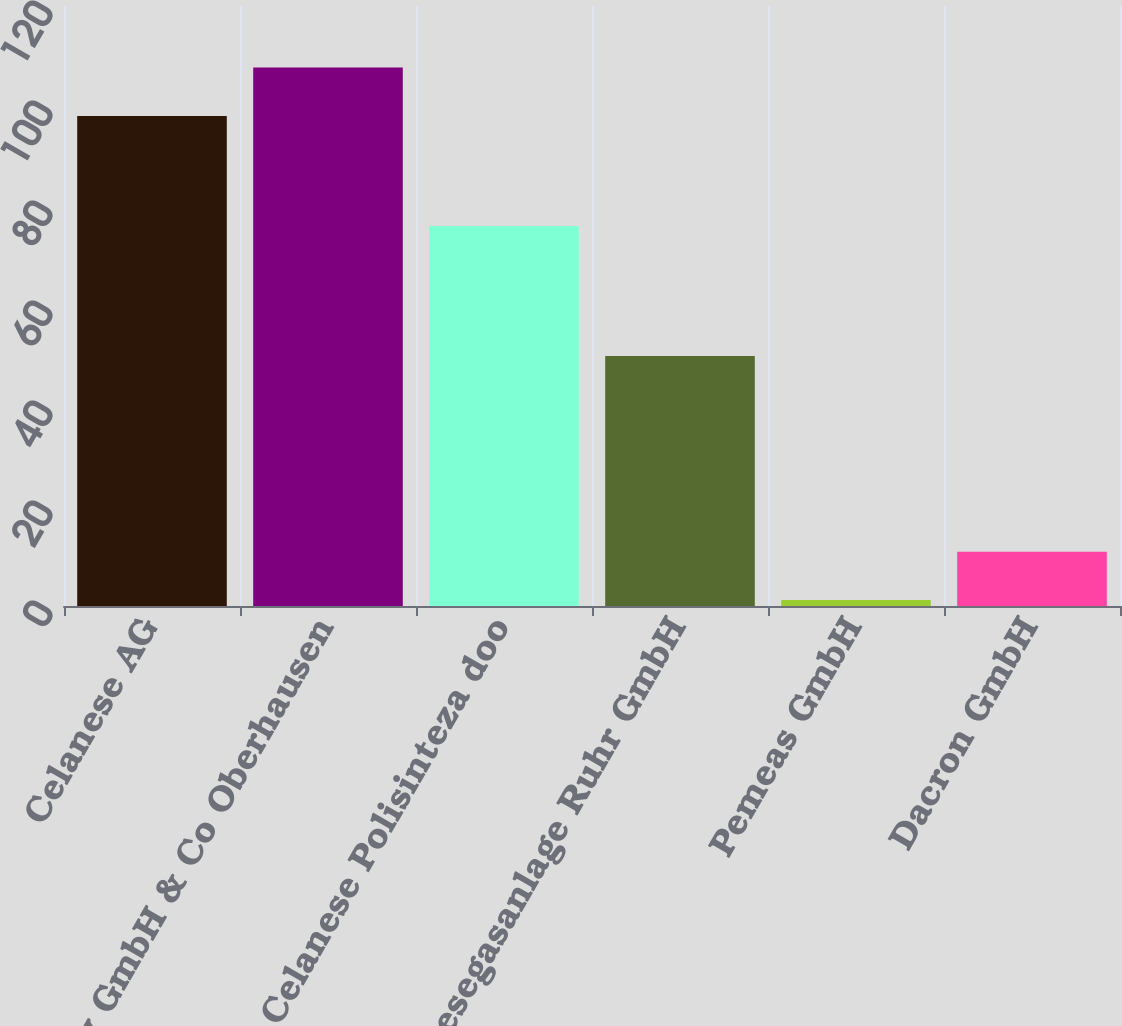Convert chart. <chart><loc_0><loc_0><loc_500><loc_500><bar_chart><fcel>Celanese AG<fcel>InfraServ GmbH & Co Oberhausen<fcel>Celanese Polisinteza doo<fcel>Synthesegasanlage Ruhr GmbH<fcel>Pemeas GmbH<fcel>Dacron GmbH<nl><fcel>98<fcel>107.68<fcel>76<fcel>50<fcel>1.19<fcel>10.87<nl></chart> 